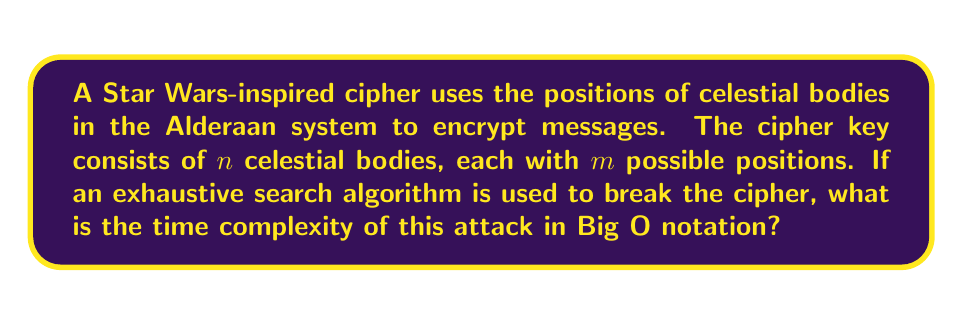Give your solution to this math problem. To analyze the time complexity of breaking this celestial body-inspired cipher, we need to consider the following steps:

1. The cipher key consists of $n$ celestial bodies, each with $m$ possible positions.

2. To perform an exhaustive search (brute-force attack), we need to try all possible combinations of positions for all celestial bodies.

3. For each celestial body, we have $m$ choices.

4. Since we have $n$ celestial bodies, and each choice is independent, we multiply the number of choices for each body:

   $$\text{Total number of combinations} = m \times m \times \ldots \times m \text{ ($n$ times)} = m^n$$

5. In the worst-case scenario, we might need to try all possible combinations before finding the correct key.

6. Each attempt to decrypt the message with a given key combination takes a constant time, let's call it $c$.

7. Therefore, the total time taken for the exhaustive search is:

   $$\text{Total time} = c \times m^n$$

8. In Big O notation, we ignore constant factors, so we can drop the $c$.

9. The time complexity of the attack is thus $O(m^n)$.

This exponential time complexity demonstrates why increasing the number of celestial bodies or their possible positions can significantly enhance the security of the cipher against brute-force attacks.
Answer: $O(m^n)$ 